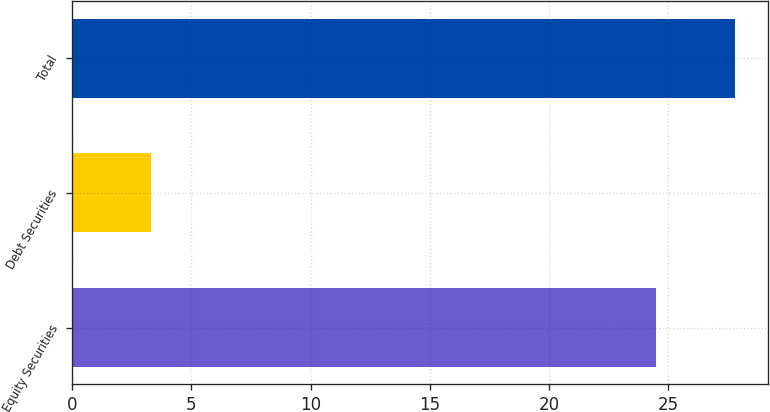Convert chart to OTSL. <chart><loc_0><loc_0><loc_500><loc_500><bar_chart><fcel>Equity Securities<fcel>Debt Securities<fcel>Total<nl><fcel>24.5<fcel>3.3<fcel>27.8<nl></chart> 